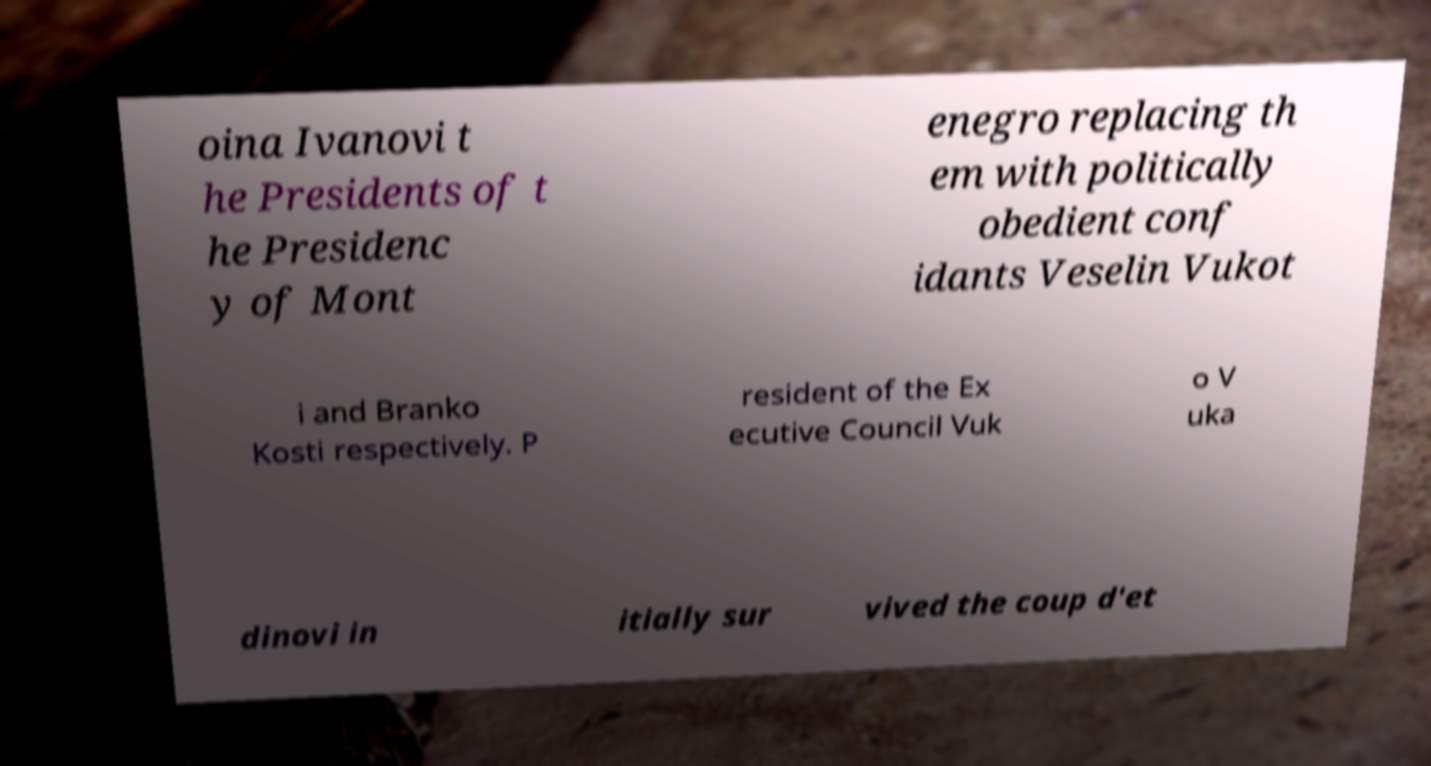I need the written content from this picture converted into text. Can you do that? oina Ivanovi t he Presidents of t he Presidenc y of Mont enegro replacing th em with politically obedient conf idants Veselin Vukot i and Branko Kosti respectively. P resident of the Ex ecutive Council Vuk o V uka dinovi in itially sur vived the coup d'et 